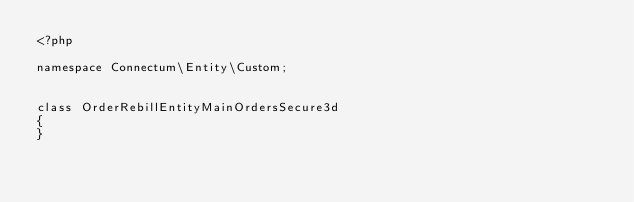<code> <loc_0><loc_0><loc_500><loc_500><_PHP_><?php

namespace Connectum\Entity\Custom;


class OrderRebillEntityMainOrdersSecure3d 
{     
}</code> 